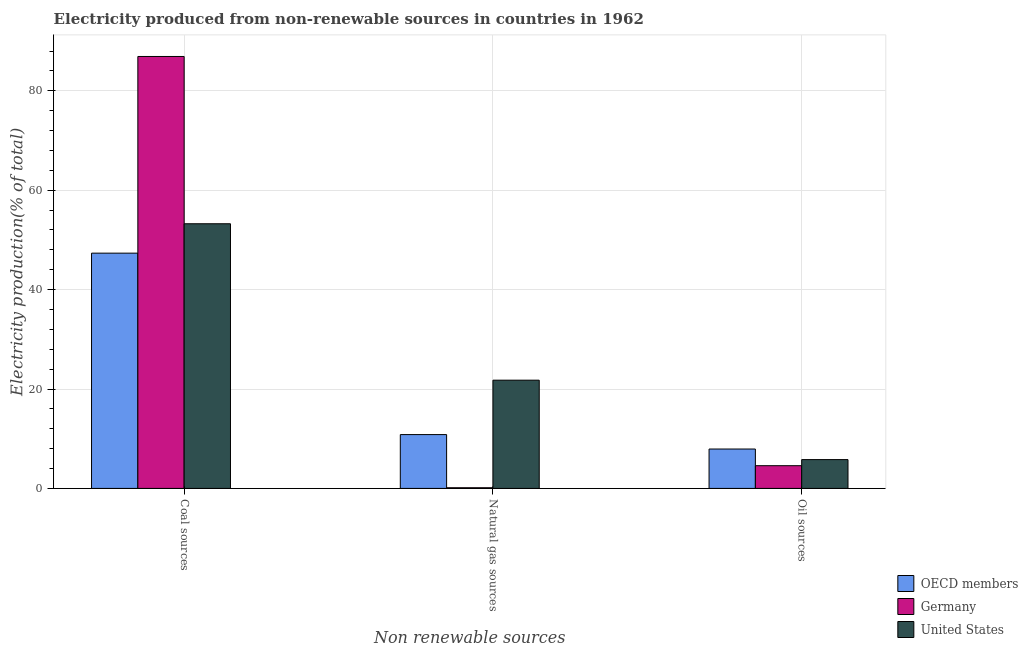How many different coloured bars are there?
Your answer should be compact. 3. Are the number of bars on each tick of the X-axis equal?
Give a very brief answer. Yes. How many bars are there on the 3rd tick from the left?
Offer a very short reply. 3. What is the label of the 1st group of bars from the left?
Your response must be concise. Coal sources. What is the percentage of electricity produced by oil sources in OECD members?
Offer a terse response. 7.93. Across all countries, what is the maximum percentage of electricity produced by oil sources?
Your answer should be very brief. 7.93. Across all countries, what is the minimum percentage of electricity produced by coal?
Make the answer very short. 47.34. In which country was the percentage of electricity produced by coal minimum?
Provide a short and direct response. OECD members. What is the total percentage of electricity produced by coal in the graph?
Make the answer very short. 187.5. What is the difference between the percentage of electricity produced by natural gas in OECD members and that in United States?
Keep it short and to the point. -10.95. What is the difference between the percentage of electricity produced by natural gas in Germany and the percentage of electricity produced by oil sources in United States?
Offer a very short reply. -5.66. What is the average percentage of electricity produced by coal per country?
Your response must be concise. 62.5. What is the difference between the percentage of electricity produced by oil sources and percentage of electricity produced by coal in United States?
Provide a succinct answer. -47.45. In how many countries, is the percentage of electricity produced by oil sources greater than 80 %?
Your response must be concise. 0. What is the ratio of the percentage of electricity produced by oil sources in United States to that in Germany?
Offer a terse response. 1.27. Is the percentage of electricity produced by oil sources in Germany less than that in OECD members?
Your answer should be compact. Yes. Is the difference between the percentage of electricity produced by oil sources in OECD members and United States greater than the difference between the percentage of electricity produced by natural gas in OECD members and United States?
Your answer should be compact. Yes. What is the difference between the highest and the second highest percentage of electricity produced by natural gas?
Ensure brevity in your answer.  10.95. What is the difference between the highest and the lowest percentage of electricity produced by coal?
Provide a short and direct response. 39.57. In how many countries, is the percentage of electricity produced by coal greater than the average percentage of electricity produced by coal taken over all countries?
Your answer should be compact. 1. What does the 3rd bar from the right in Oil sources represents?
Make the answer very short. OECD members. How many bars are there?
Offer a terse response. 9. How many countries are there in the graph?
Keep it short and to the point. 3. What is the difference between two consecutive major ticks on the Y-axis?
Offer a very short reply. 20. Are the values on the major ticks of Y-axis written in scientific E-notation?
Offer a very short reply. No. Where does the legend appear in the graph?
Make the answer very short. Bottom right. How are the legend labels stacked?
Your answer should be very brief. Vertical. What is the title of the graph?
Give a very brief answer. Electricity produced from non-renewable sources in countries in 1962. What is the label or title of the X-axis?
Provide a short and direct response. Non renewable sources. What is the label or title of the Y-axis?
Ensure brevity in your answer.  Electricity production(% of total). What is the Electricity production(% of total) of OECD members in Coal sources?
Your response must be concise. 47.34. What is the Electricity production(% of total) of Germany in Coal sources?
Your answer should be compact. 86.91. What is the Electricity production(% of total) in United States in Coal sources?
Give a very brief answer. 53.25. What is the Electricity production(% of total) in OECD members in Natural gas sources?
Offer a very short reply. 10.83. What is the Electricity production(% of total) in Germany in Natural gas sources?
Ensure brevity in your answer.  0.14. What is the Electricity production(% of total) of United States in Natural gas sources?
Keep it short and to the point. 21.78. What is the Electricity production(% of total) in OECD members in Oil sources?
Your answer should be compact. 7.93. What is the Electricity production(% of total) of Germany in Oil sources?
Your answer should be very brief. 4.57. What is the Electricity production(% of total) of United States in Oil sources?
Offer a very short reply. 5.8. Across all Non renewable sources, what is the maximum Electricity production(% of total) in OECD members?
Ensure brevity in your answer.  47.34. Across all Non renewable sources, what is the maximum Electricity production(% of total) in Germany?
Keep it short and to the point. 86.91. Across all Non renewable sources, what is the maximum Electricity production(% of total) of United States?
Provide a short and direct response. 53.25. Across all Non renewable sources, what is the minimum Electricity production(% of total) in OECD members?
Your answer should be very brief. 7.93. Across all Non renewable sources, what is the minimum Electricity production(% of total) of Germany?
Ensure brevity in your answer.  0.14. Across all Non renewable sources, what is the minimum Electricity production(% of total) of United States?
Your answer should be very brief. 5.8. What is the total Electricity production(% of total) of OECD members in the graph?
Your response must be concise. 66.09. What is the total Electricity production(% of total) in Germany in the graph?
Your answer should be very brief. 91.62. What is the total Electricity production(% of total) in United States in the graph?
Keep it short and to the point. 80.83. What is the difference between the Electricity production(% of total) of OECD members in Coal sources and that in Natural gas sources?
Provide a succinct answer. 36.51. What is the difference between the Electricity production(% of total) in Germany in Coal sources and that in Natural gas sources?
Your answer should be very brief. 86.77. What is the difference between the Electricity production(% of total) of United States in Coal sources and that in Natural gas sources?
Your response must be concise. 31.47. What is the difference between the Electricity production(% of total) of OECD members in Coal sources and that in Oil sources?
Provide a succinct answer. 39.41. What is the difference between the Electricity production(% of total) in Germany in Coal sources and that in Oil sources?
Offer a terse response. 82.34. What is the difference between the Electricity production(% of total) of United States in Coal sources and that in Oil sources?
Your response must be concise. 47.45. What is the difference between the Electricity production(% of total) of OECD members in Natural gas sources and that in Oil sources?
Your answer should be very brief. 2.91. What is the difference between the Electricity production(% of total) of Germany in Natural gas sources and that in Oil sources?
Ensure brevity in your answer.  -4.44. What is the difference between the Electricity production(% of total) in United States in Natural gas sources and that in Oil sources?
Provide a succinct answer. 15.98. What is the difference between the Electricity production(% of total) of OECD members in Coal sources and the Electricity production(% of total) of Germany in Natural gas sources?
Make the answer very short. 47.2. What is the difference between the Electricity production(% of total) in OECD members in Coal sources and the Electricity production(% of total) in United States in Natural gas sources?
Your answer should be very brief. 25.56. What is the difference between the Electricity production(% of total) of Germany in Coal sources and the Electricity production(% of total) of United States in Natural gas sources?
Provide a short and direct response. 65.13. What is the difference between the Electricity production(% of total) of OECD members in Coal sources and the Electricity production(% of total) of Germany in Oil sources?
Your answer should be compact. 42.76. What is the difference between the Electricity production(% of total) in OECD members in Coal sources and the Electricity production(% of total) in United States in Oil sources?
Your answer should be very brief. 41.54. What is the difference between the Electricity production(% of total) of Germany in Coal sources and the Electricity production(% of total) of United States in Oil sources?
Offer a terse response. 81.11. What is the difference between the Electricity production(% of total) in OECD members in Natural gas sources and the Electricity production(% of total) in Germany in Oil sources?
Keep it short and to the point. 6.26. What is the difference between the Electricity production(% of total) of OECD members in Natural gas sources and the Electricity production(% of total) of United States in Oil sources?
Your answer should be compact. 5.03. What is the difference between the Electricity production(% of total) in Germany in Natural gas sources and the Electricity production(% of total) in United States in Oil sources?
Your response must be concise. -5.66. What is the average Electricity production(% of total) of OECD members per Non renewable sources?
Offer a very short reply. 22.03. What is the average Electricity production(% of total) of Germany per Non renewable sources?
Make the answer very short. 30.54. What is the average Electricity production(% of total) of United States per Non renewable sources?
Offer a terse response. 26.94. What is the difference between the Electricity production(% of total) of OECD members and Electricity production(% of total) of Germany in Coal sources?
Your answer should be compact. -39.57. What is the difference between the Electricity production(% of total) of OECD members and Electricity production(% of total) of United States in Coal sources?
Ensure brevity in your answer.  -5.91. What is the difference between the Electricity production(% of total) of Germany and Electricity production(% of total) of United States in Coal sources?
Provide a succinct answer. 33.66. What is the difference between the Electricity production(% of total) of OECD members and Electricity production(% of total) of Germany in Natural gas sources?
Your answer should be compact. 10.7. What is the difference between the Electricity production(% of total) of OECD members and Electricity production(% of total) of United States in Natural gas sources?
Offer a terse response. -10.95. What is the difference between the Electricity production(% of total) of Germany and Electricity production(% of total) of United States in Natural gas sources?
Offer a very short reply. -21.64. What is the difference between the Electricity production(% of total) in OECD members and Electricity production(% of total) in Germany in Oil sources?
Offer a very short reply. 3.35. What is the difference between the Electricity production(% of total) in OECD members and Electricity production(% of total) in United States in Oil sources?
Give a very brief answer. 2.13. What is the difference between the Electricity production(% of total) in Germany and Electricity production(% of total) in United States in Oil sources?
Your response must be concise. -1.23. What is the ratio of the Electricity production(% of total) of OECD members in Coal sources to that in Natural gas sources?
Provide a succinct answer. 4.37. What is the ratio of the Electricity production(% of total) of Germany in Coal sources to that in Natural gas sources?
Provide a succinct answer. 637.97. What is the ratio of the Electricity production(% of total) of United States in Coal sources to that in Natural gas sources?
Offer a very short reply. 2.45. What is the ratio of the Electricity production(% of total) in OECD members in Coal sources to that in Oil sources?
Your answer should be very brief. 5.97. What is the ratio of the Electricity production(% of total) of Germany in Coal sources to that in Oil sources?
Your response must be concise. 19.01. What is the ratio of the Electricity production(% of total) of United States in Coal sources to that in Oil sources?
Make the answer very short. 9.18. What is the ratio of the Electricity production(% of total) in OECD members in Natural gas sources to that in Oil sources?
Provide a succinct answer. 1.37. What is the ratio of the Electricity production(% of total) of Germany in Natural gas sources to that in Oil sources?
Provide a short and direct response. 0.03. What is the ratio of the Electricity production(% of total) in United States in Natural gas sources to that in Oil sources?
Your answer should be very brief. 3.76. What is the difference between the highest and the second highest Electricity production(% of total) of OECD members?
Provide a short and direct response. 36.51. What is the difference between the highest and the second highest Electricity production(% of total) of Germany?
Your answer should be very brief. 82.34. What is the difference between the highest and the second highest Electricity production(% of total) in United States?
Ensure brevity in your answer.  31.47. What is the difference between the highest and the lowest Electricity production(% of total) of OECD members?
Ensure brevity in your answer.  39.41. What is the difference between the highest and the lowest Electricity production(% of total) of Germany?
Keep it short and to the point. 86.77. What is the difference between the highest and the lowest Electricity production(% of total) of United States?
Make the answer very short. 47.45. 